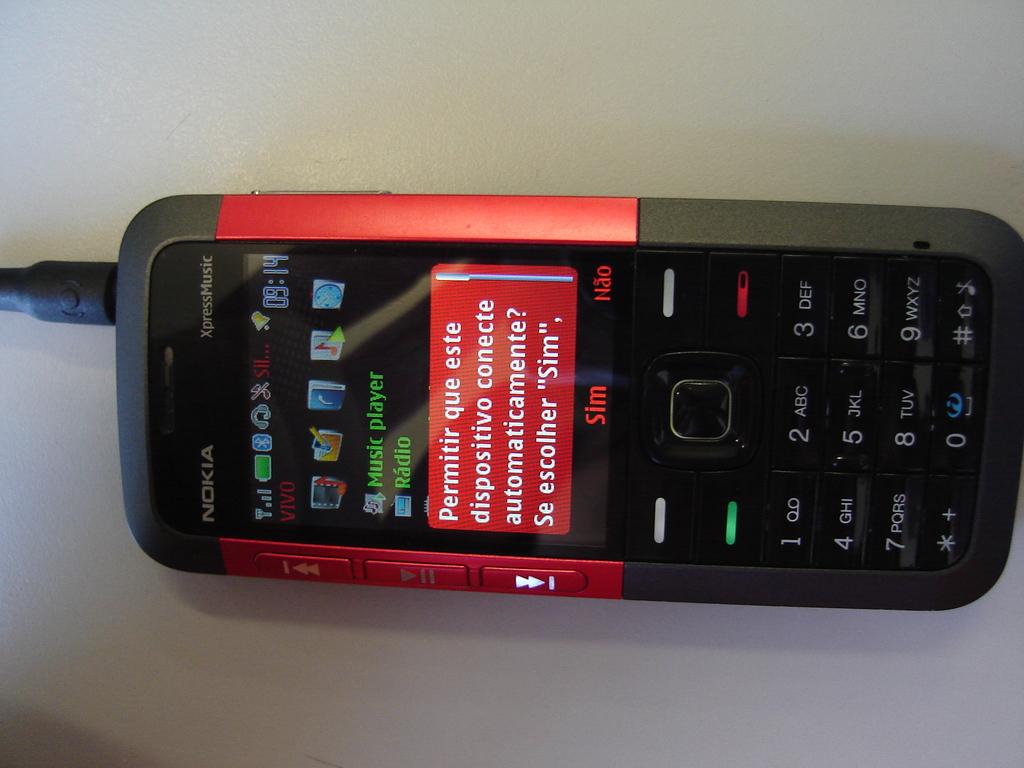Is this a nokia phone?
Your answer should be very brief. Yes. Does this phone have a music player?
Offer a very short reply. Yes. 